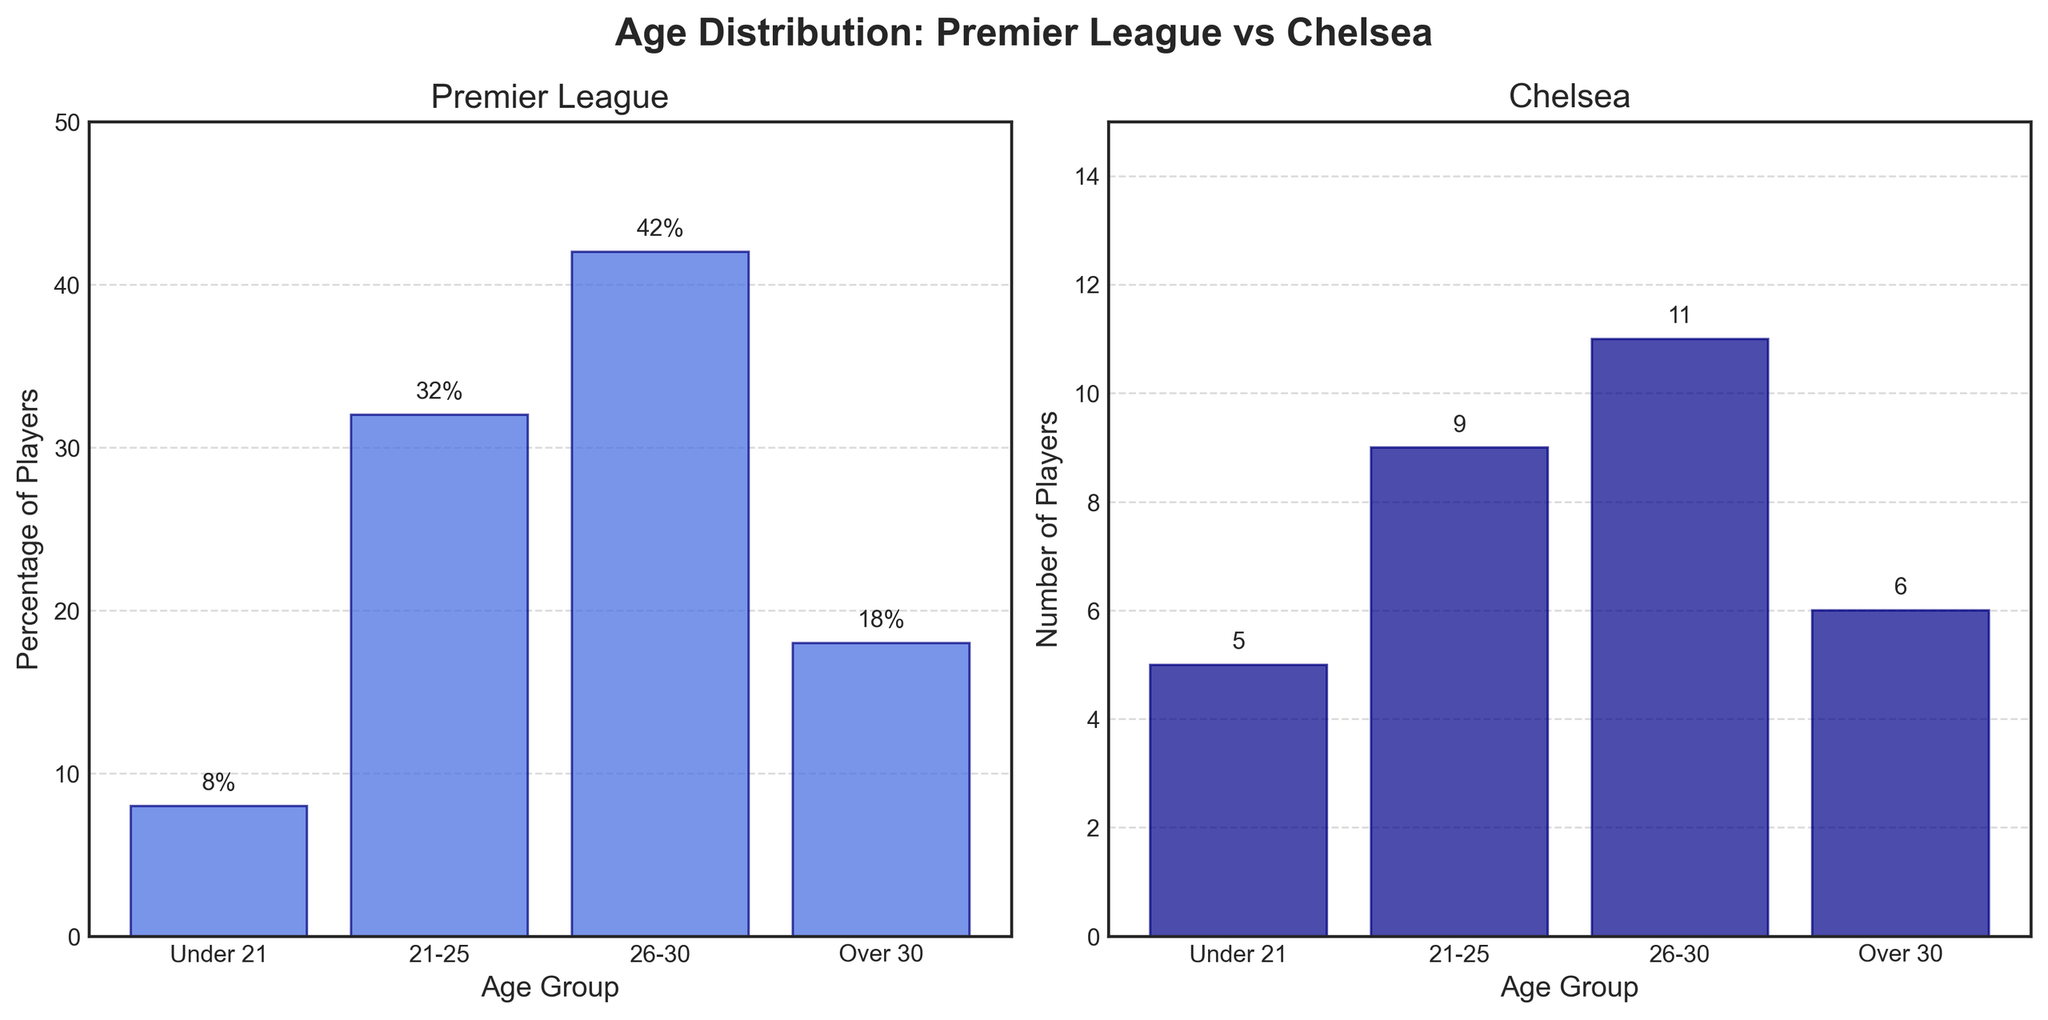What is the age group classification used in the figure? The age group classification is provided along the x-axis in both subplots. The groups are labeled as "Under 21", "21-25", "26-30", and "Over 30".
Answer: Under 21, 21-25, 26-30, Over 30 Which age group has the highest percentage of players in the Premier League? By looking at the Premier League subplot on the left, the "26-30" age group has the highest bar reaching 42%.
Answer: 26-30 How many Chelsea players are in the "Over 30" age group? The Chelsea subplot on the right-side shows that the "Over 30" age group has a bar reaching up to 6.
Answer: 6 What is the difference in the percentage of Premier League players between the "21-25" and "26-30" age groups? The percentages can be compared directly. "21-25" has 32%, and "26-30" has 42%. The difference is 42% - 32% = 10%.
Answer: 10% Compare the number of players between the "Under 21" age group of Chelsea and the "Over 30" age group of the Premier League. Chelsea's "Under 21" age group has 5 players, while the Premier League's "Over 30" group has 18%.
Answer: Chelsea: 5, Premier League: 18% Which age group has fewer players in Chelsea compared to the Premier League? By comparing both subplots, the "21-25", "26-30", and "Over 30" age groups have fewer players in Chelsea compared to the percentages in the Premier League.
Answer: 21-25, 26-30, Over 30 What is the total number of Chelsea players in the "21-25" and "26-30" age groups combined? Adding the number of players in Chelsea's "21-25" group (9) and "26-30" group (11), we get 9 + 11 = 20.
Answer: 20 What is the range of the y-axis for the Chelsea subplot? For the Chelsea subplot on the right, the y-axis ranges from 0 to 15.
Answer: 0 to 15 How does the proportion of "Under 21" players in Chelsea compare with the Premier League? Comparing the two subplots, Chelsea has 5 players "Under 21", whereas the Premier League has 8% in this age group. Chelsea's number is less in comparison to the Premier League's percentage.
Answer: Chelsea has less What is the percentage difference between the "Over 30" age group and the "Under 21" age group in the Premier League? Premier League's "Over 30" group has 18%, and "Under 21" group has 8%. The difference is 18% - 8% = 10%.
Answer: 10% 